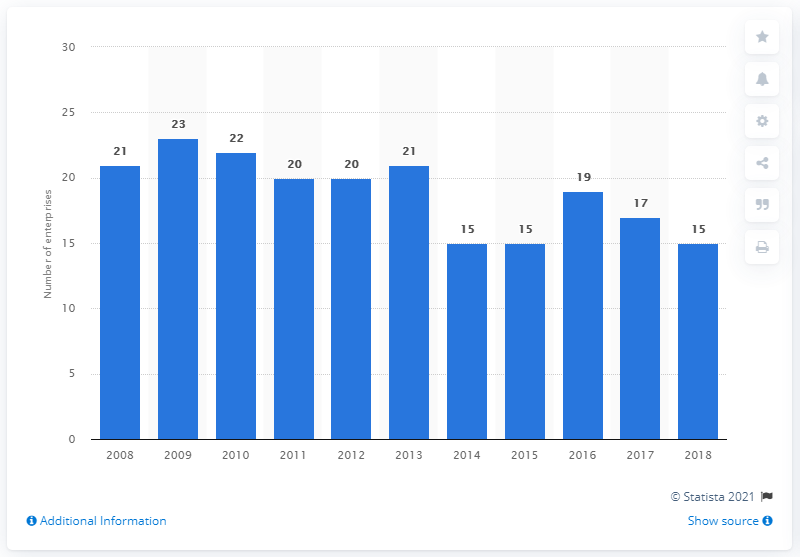Highlight a few significant elements in this photo. In 2018, there were 15 manufacturing enterprises in Malta that produced beverages. 